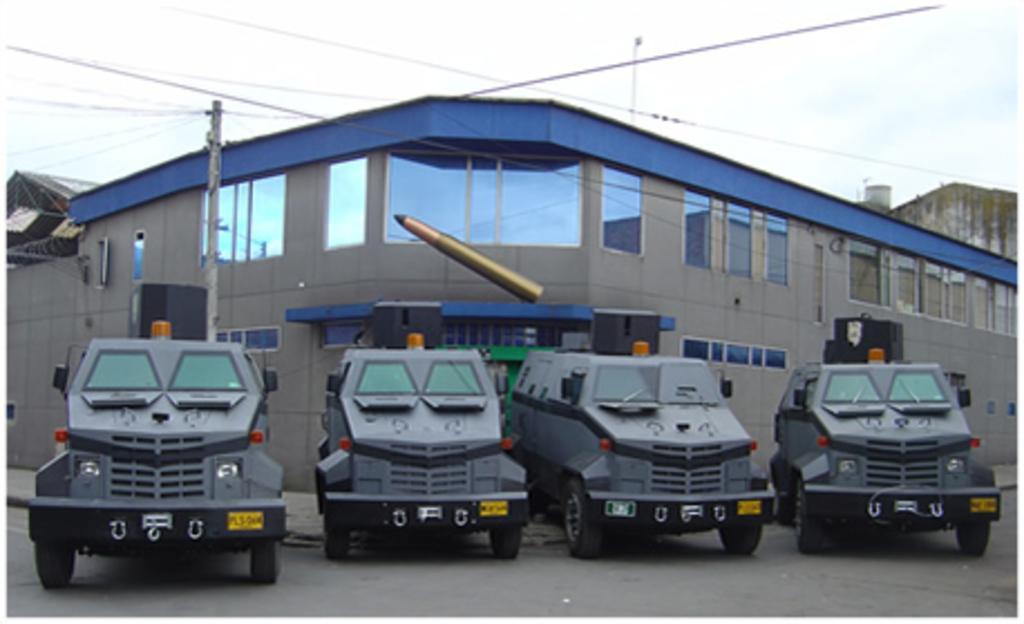In one or two sentences, can you explain what this image depicts? In this image in front there are four vehicles on the road. Behind the vehicle there is a current pole with wires. In the background of the image there are buildings and sky. In the center of the image there is a bullet. 